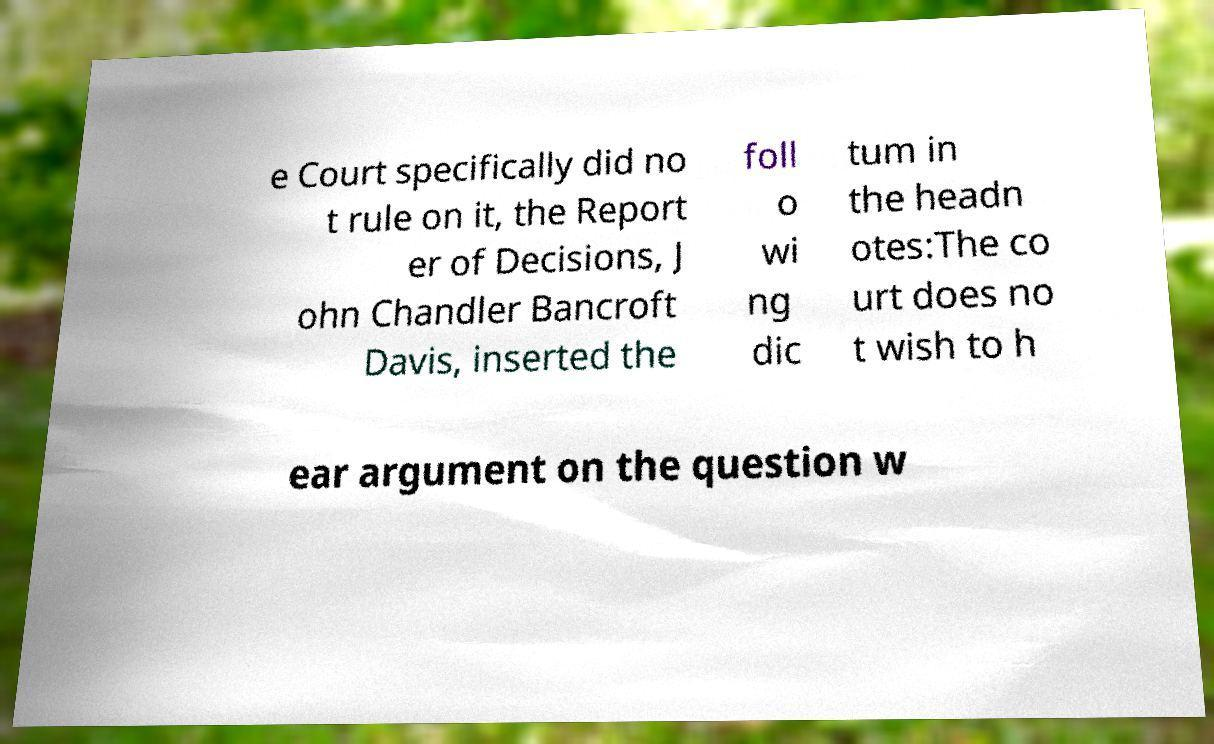Can you read and provide the text displayed in the image?This photo seems to have some interesting text. Can you extract and type it out for me? e Court specifically did no t rule on it, the Report er of Decisions, J ohn Chandler Bancroft Davis, inserted the foll o wi ng dic tum in the headn otes:The co urt does no t wish to h ear argument on the question w 